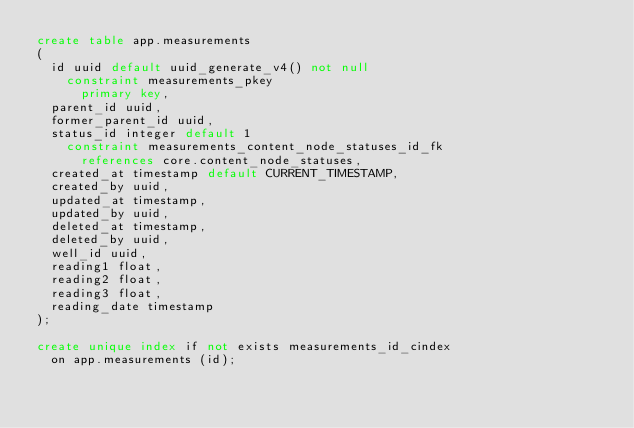Convert code to text. <code><loc_0><loc_0><loc_500><loc_500><_SQL_>create table app.measurements
(
  id uuid default uuid_generate_v4() not null
    constraint measurements_pkey
      primary key,
  parent_id uuid,
  former_parent_id uuid,
  status_id integer default 1
    constraint measurements_content_node_statuses_id_fk
      references core.content_node_statuses,
  created_at timestamp default CURRENT_TIMESTAMP,
  created_by uuid,
  updated_at timestamp,
  updated_by uuid,
  deleted_at timestamp,
  deleted_by uuid,
  well_id uuid,
  reading1 float,
  reading2 float,
  reading3 float,
  reading_date timestamp
);

create unique index if not exists measurements_id_cindex
  on app.measurements (id);
</code> 